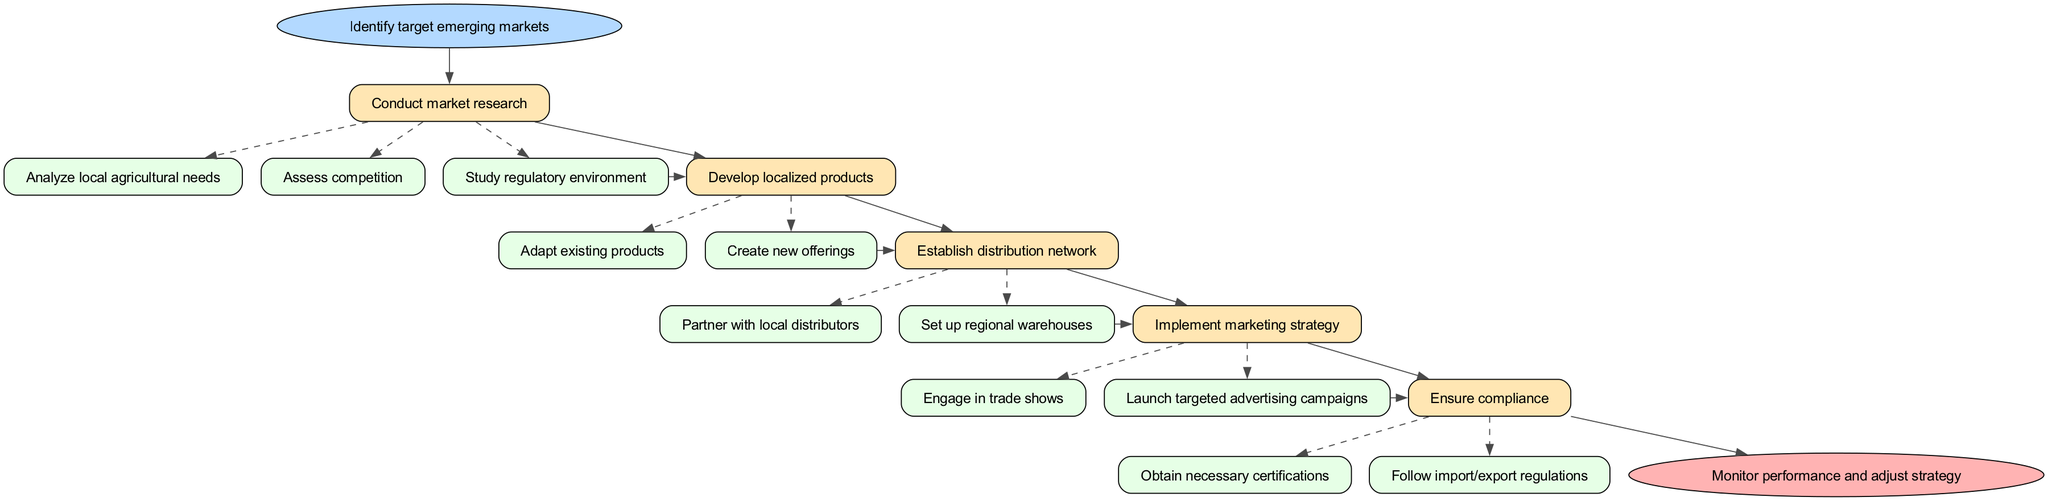What is the starting point of the diagram? The starting point is labeled "Identify target emerging markets," which is indicated at the top of the flow chart in an ellipse shape.
Answer: Identify target emerging markets How many main steps are there in this strategy? By counting the boxes representing each main step directly below the start point, we identify that there are five main steps in the diagram.
Answer: 5 What is one of the substeps under "Conduct market research"? The first substep listed under "Conduct market research" is "Analyze local agricultural needs," which is shown as a dashed-edged box connected to the "Conduct market research" step.
Answer: Analyze local agricultural needs Which step comes immediately after "Develop localized products"? By following the flow of the diagram, it shows that "Establish distribution network" is the step that follows "Develop localized products."
Answer: Establish distribution network What color represents the end node in the diagram? The end node, labeled "Monitor performance and adjust strategy," is in an ellipse shape filled with a red color, specifically indicated in pinkish shades in the diagram.
Answer: Pink How does "Ensure compliance" relate to the previous step? The substeps of "Ensure compliance" come after completing "Implement marketing strategy," as indicated by the arrow connecting these two steps in the flow, indicating a sequential relationship.
Answer: Sequential relationship What type of action is represented by the arrow from "Conduct market research" to "Develop localized products"? The arrow indicates a directional flow, showing that results or requirements from "Conduct market research" feed into the next step "Develop localized products," signifying a logical progression in the strategy.
Answer: Progression How many substeps are there under "Implement marketing strategy"? After directly counting the dashed boxes under "Implement marketing strategy," we find that there are two substeps listed; thus, the total is two.
Answer: 2 What is the significance of the dashed lines linking the substeps? The dashed lines signify that those substeps are detailed actions related to their respective main step, indicating a branching path within that specific strategy phase.
Answer: Detailed actions 